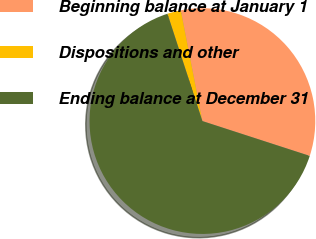Convert chart. <chart><loc_0><loc_0><loc_500><loc_500><pie_chart><fcel>Beginning balance at January 1<fcel>Dispositions and other<fcel>Ending balance at December 31<nl><fcel>33.06%<fcel>1.94%<fcel>64.99%<nl></chart> 